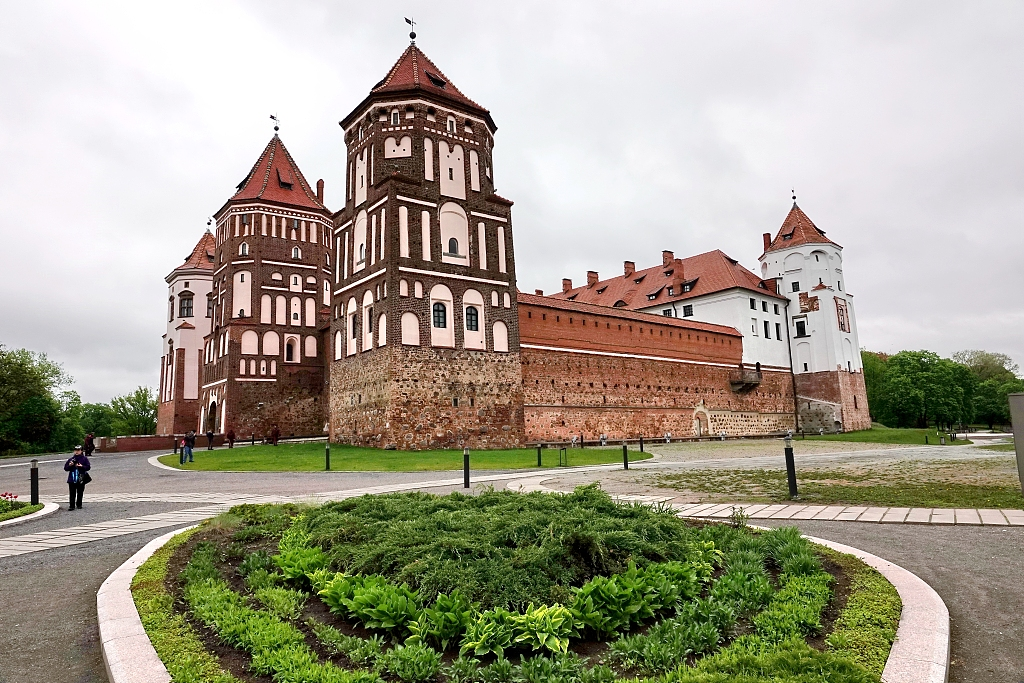Who might have lived in such a grand structure? The Mir Castle was originally built by the noble Ilyinich family, prominent figures in the Grand Duchy of Lithuania. Later, it came into the possession of the Radziwill family, one of the most influential and wealthiest families in the region. They were patrons of the arts, military leaders, and influential politicians. Living within such grandeur, the inhabitants would have been surrounded by wealth, luxury, and power. The castle would host grandiose events, balls, and feasts, attended by other nobles and dignitaries. It was not just a home; it was a symbol of status and influence.  Imagine that one of the castle's towers has been turned into a time-travelling observatory. What adventures might it have witnessed? Imagine stepping into a tower at Mir Castle, transformed into a time-travelling observatory. Through its enchanted telescopes, one might have witnessed the construction of the Great Wall of China, the signing of the Magna Carta, or the grandeur of Cleopatra’s Alexandria. In another moment, the observer might find themselves in the midst of a bustling Renaissance fair, with Leonardo da Vinci sketching his inventions nearby. The observatory might also offer glimpses into the future: the awe-inspiring skyscrapers of 22nd-century cities, humans living on Mars, or breathtaking adventures in underwater metropolises. The tower stands not just as a witness to history but as a portal to endless adventures across time, brimming with tales of past and future marvels. 